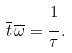Convert formula to latex. <formula><loc_0><loc_0><loc_500><loc_500>\overline { t } \, \overline { \omega } = \cfrac { 1 } { \tau } \, .</formula> 